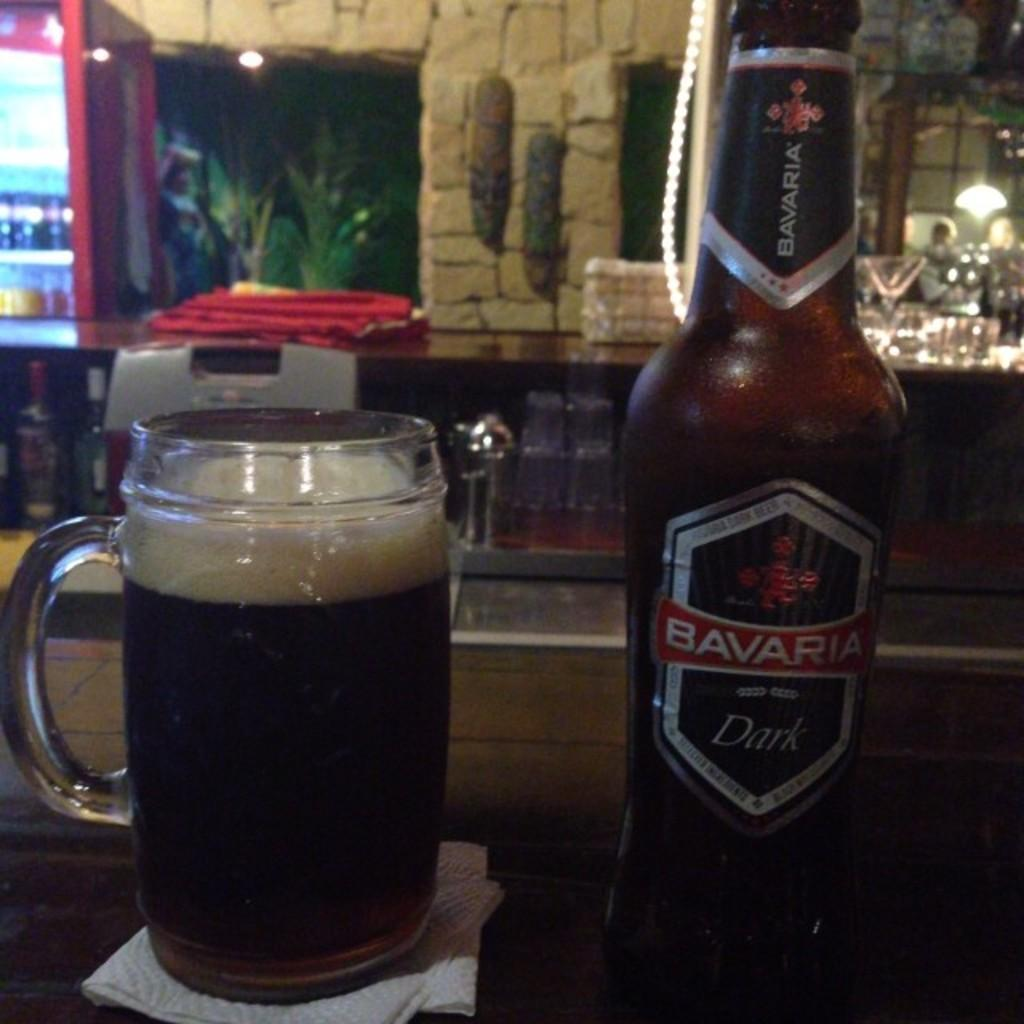<image>
Write a terse but informative summary of the picture. A bottle of Bavaria Dark next to a glass of it 